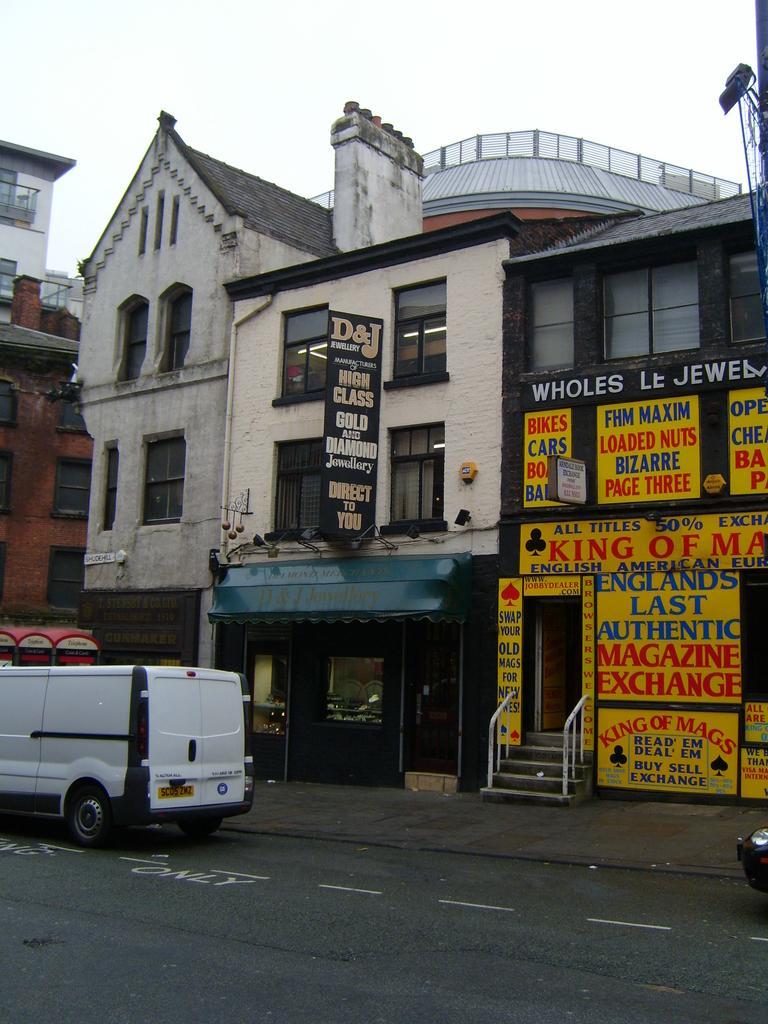In one or two sentences, can you explain what this image depicts? In this image in the center there are some buildings, boards, stairs, railing. On the boards there is text, on the right side there is a camera and pole. At the bottom there is road, on the right side and left side there are vehicles. At the top there is sky. 